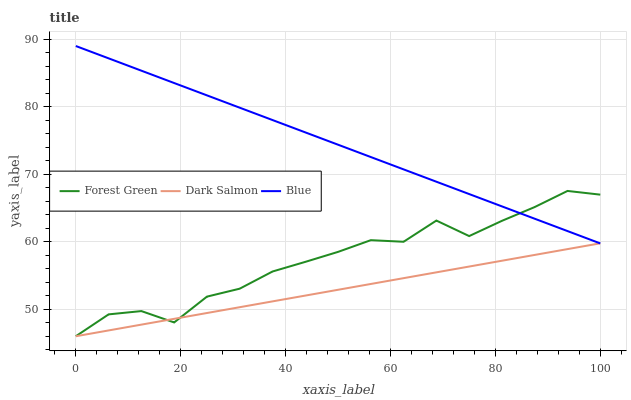Does Dark Salmon have the minimum area under the curve?
Answer yes or no. Yes. Does Blue have the maximum area under the curve?
Answer yes or no. Yes. Does Forest Green have the minimum area under the curve?
Answer yes or no. No. Does Forest Green have the maximum area under the curve?
Answer yes or no. No. Is Dark Salmon the smoothest?
Answer yes or no. Yes. Is Forest Green the roughest?
Answer yes or no. Yes. Is Forest Green the smoothest?
Answer yes or no. No. Is Dark Salmon the roughest?
Answer yes or no. No. Does Blue have the highest value?
Answer yes or no. Yes. Does Forest Green have the highest value?
Answer yes or no. No. Does Dark Salmon intersect Blue?
Answer yes or no. Yes. Is Dark Salmon less than Blue?
Answer yes or no. No. Is Dark Salmon greater than Blue?
Answer yes or no. No. 